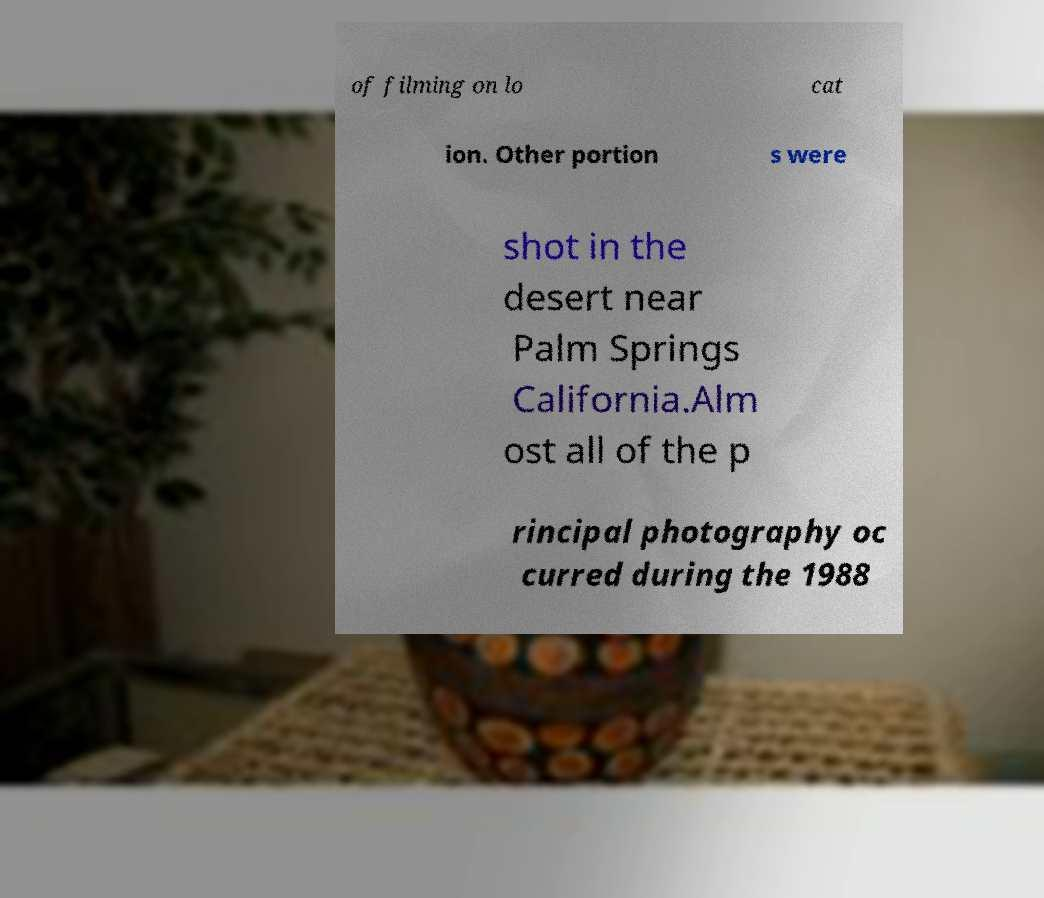I need the written content from this picture converted into text. Can you do that? of filming on lo cat ion. Other portion s were shot in the desert near Palm Springs California.Alm ost all of the p rincipal photography oc curred during the 1988 